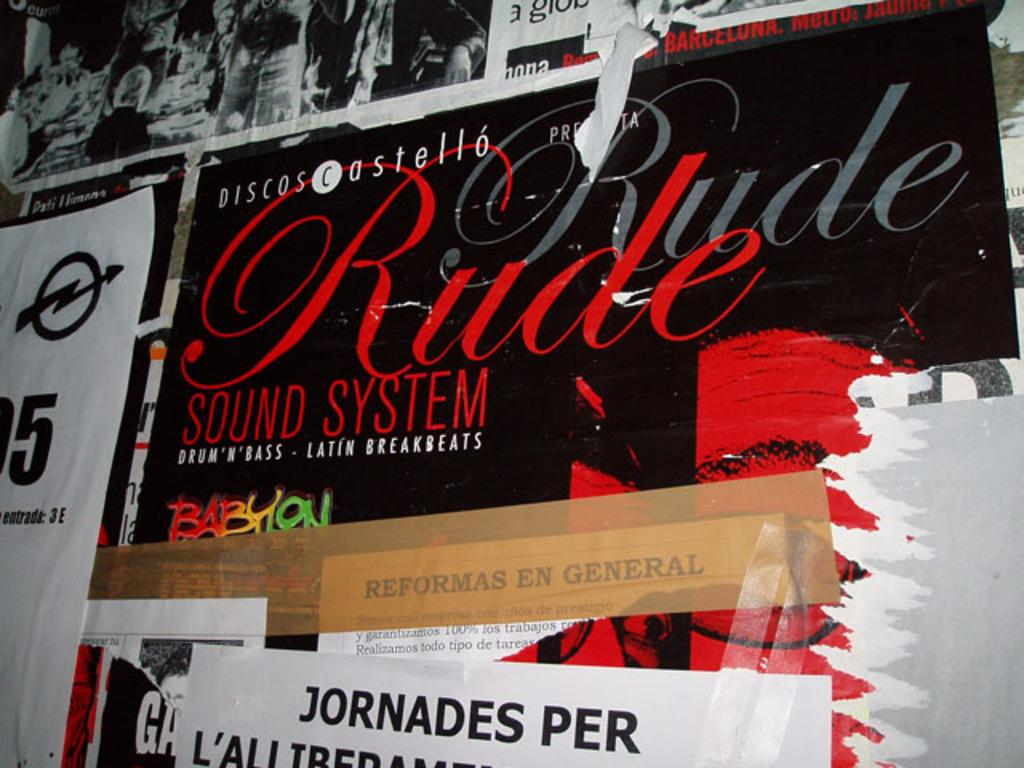<image>
Summarize the visual content of the image. A poster for a band called Rude Rude hangs from a wall with other posters 